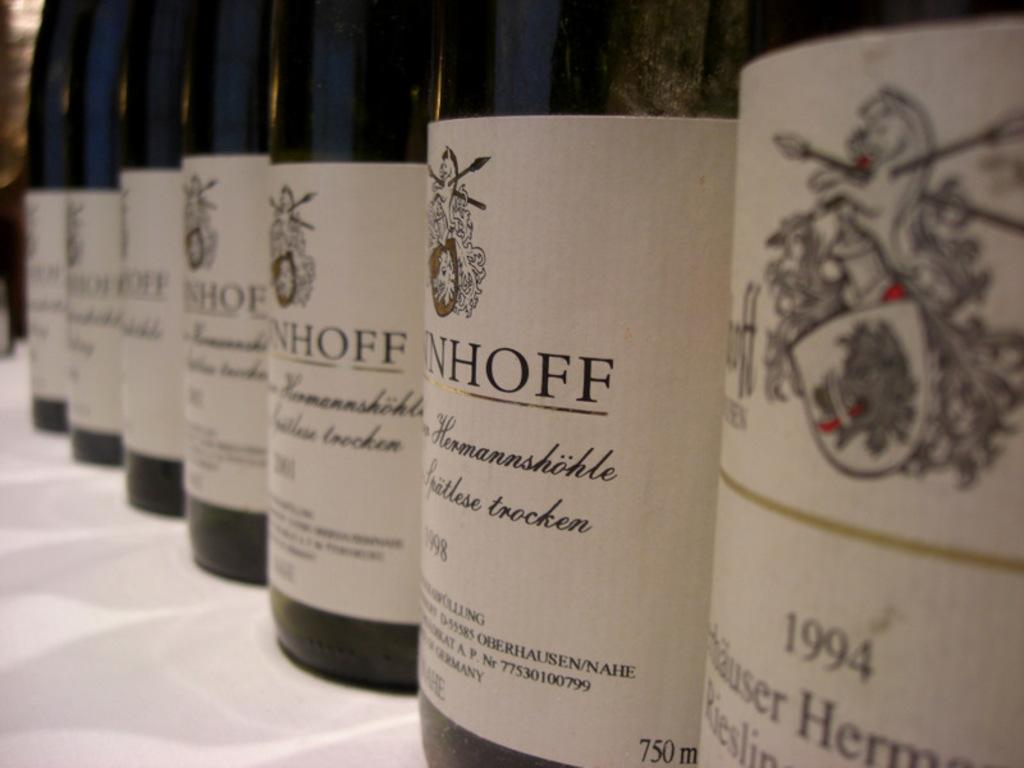<image>
Write a terse but informative summary of the picture. Several bottles of wine are being displayed for the 1994 Hermannshohle wine. 